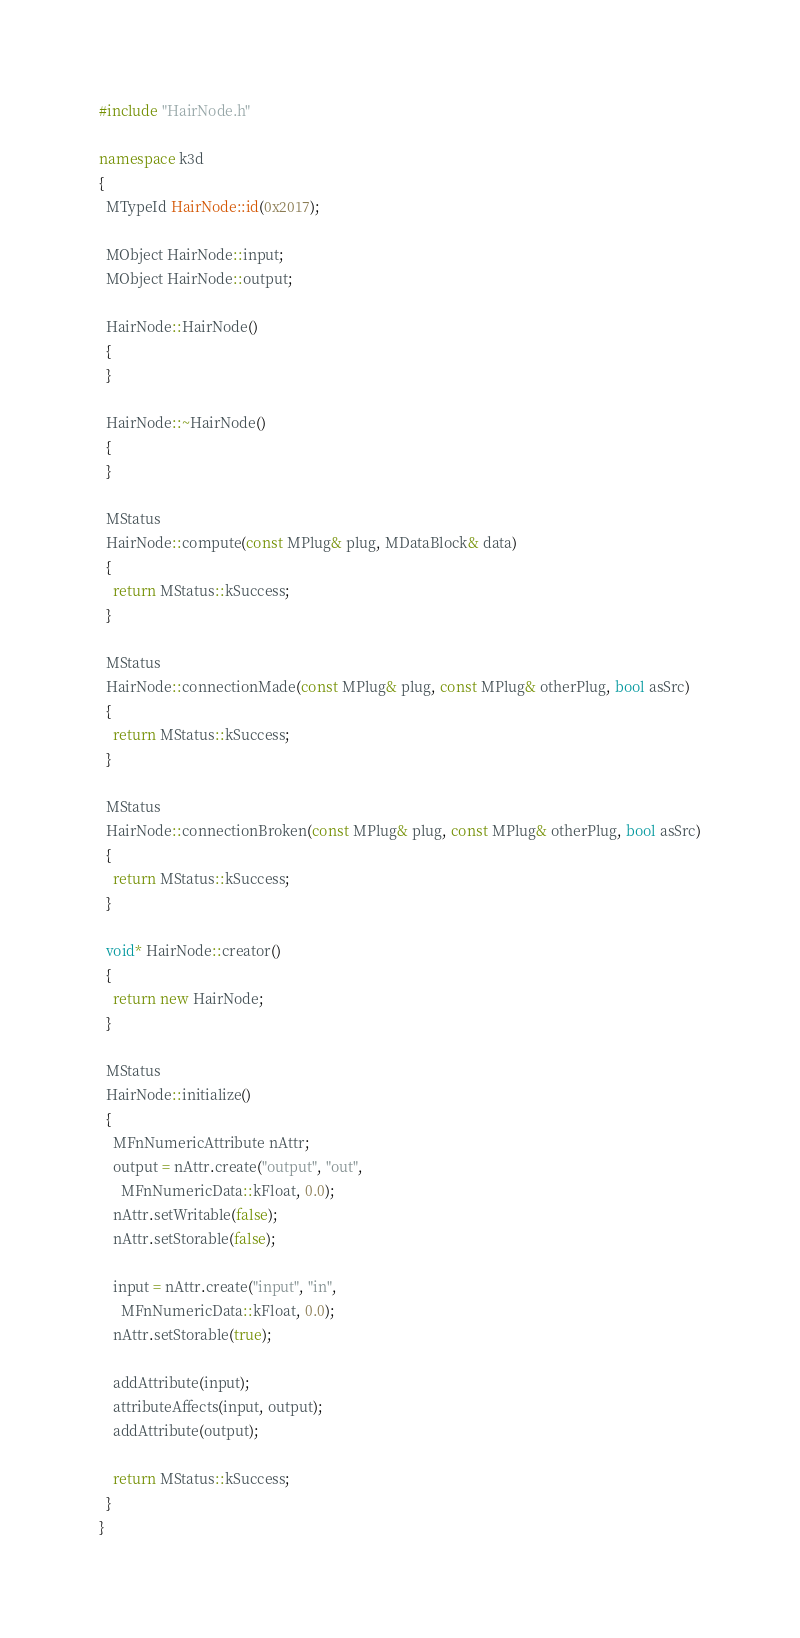<code> <loc_0><loc_0><loc_500><loc_500><_C++_>#include "HairNode.h"

namespace k3d
{
  MTypeId HairNode::id(0x2017);

  MObject HairNode::input;
  MObject HairNode::output;

  HairNode::HairNode()
  {
  }

  HairNode::~HairNode()
  {
  }
  
  MStatus
  HairNode::compute(const MPlug& plug, MDataBlock& data)
  {
    return MStatus::kSuccess;
  }

  MStatus
  HairNode::connectionMade(const MPlug& plug, const MPlug& otherPlug, bool asSrc)
  {
    return MStatus::kSuccess;
  }

  MStatus
  HairNode::connectionBroken(const MPlug& plug, const MPlug& otherPlug, bool asSrc)
  {
    return MStatus::kSuccess;
  }

  void* HairNode::creator()
  {
    return new HairNode;
  }

  MStatus
  HairNode::initialize()
  {
    MFnNumericAttribute nAttr;
    output = nAttr.create("output", "out",
      MFnNumericData::kFloat, 0.0);
    nAttr.setWritable(false);
    nAttr.setStorable(false);
    
    input = nAttr.create("input", "in",
      MFnNumericData::kFloat, 0.0);
    nAttr.setStorable(true);

    addAttribute(input);
    attributeAffects(input, output);
    addAttribute(output);

    return MStatus::kSuccess;
  }
}</code> 